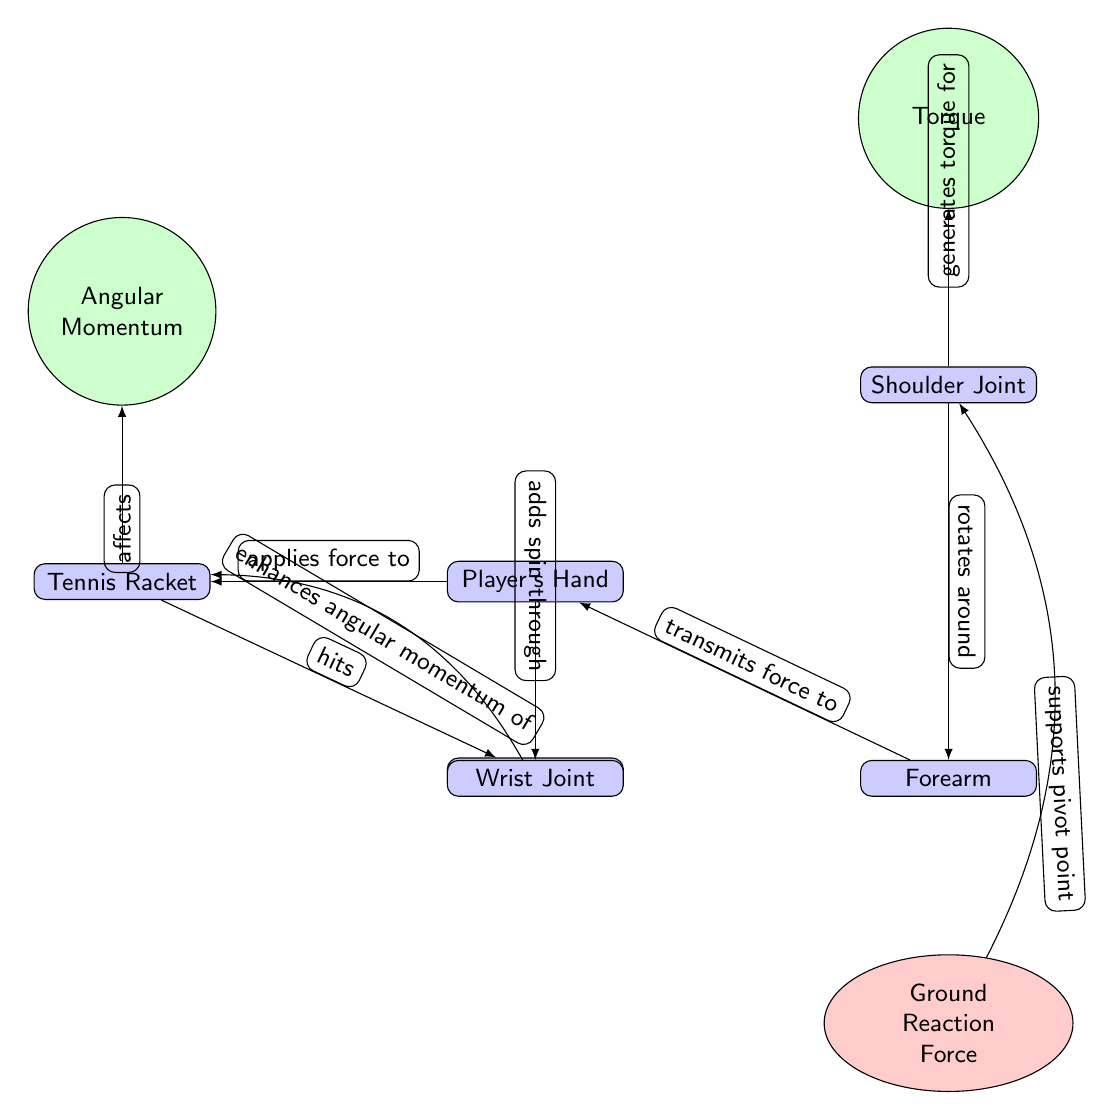What is the first object the player's hand interacts with? The player's hand applies force to the tennis racket, which is the first object it interacts with as indicated by the directed edge from hand to racket.
Answer: Tennis Racket Which joint is responsible for generating torque? The shoulder joint is indicated in the diagram as the source of torque, as it is connected to the torque concept with an arrow pointing from shoulder to torque.
Answer: Shoulder Joint How many main objects are represented in the diagram? The diagram has 6 main objects: Tennis Racket, Player's Hand, Shoulder Joint, Ball, Wrist Joint, and Forearm, as each of these is represented as a distinct node in the visual.
Answer: 6 What force acts as the pivot point in this scenario? The ground reaction force is shown below the forearm and is described as supporting the pivot point for the player's movements during the serve.
Answer: Ground Reaction Force What does the wrist enhance during the serve? The wrist, as per the diagram, enhances the angular momentum of the racket, demonstrating its role in generating spin and speed when serving.
Answer: Angular Momentum How does the forearm interact with the hand? The forearm transmits force to the hand, as depicted by the directed edge pointing from forearm to hand, indicating the physical interaction during the serve.
Answer: Transmits force What does the hand apply to the racket? The diagram explicitly states that the hand applies force to the racket, which is a key action in executing a tennis serve.
Answer: Force How does the shoulder relate to the forearm in terms of movement? The diagram shows that the shoulder rotates around the forearm, highlighting the joint kinematics involved when a player serves in tennis.
Answer: Rotates around What role does the wrist play in relation to the racket? The wrist adds spin through its action, as indicated by the directed edge from wrist to racket, which connects the two actions occurring during the serve.
Answer: Adds spin through 